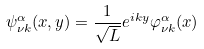<formula> <loc_0><loc_0><loc_500><loc_500>\psi ^ { \alpha } _ { \nu k } ( x , y ) = \frac { 1 } { \sqrt { L } } e ^ { i k y } \varphi ^ { \alpha } _ { \nu k } ( x )</formula> 